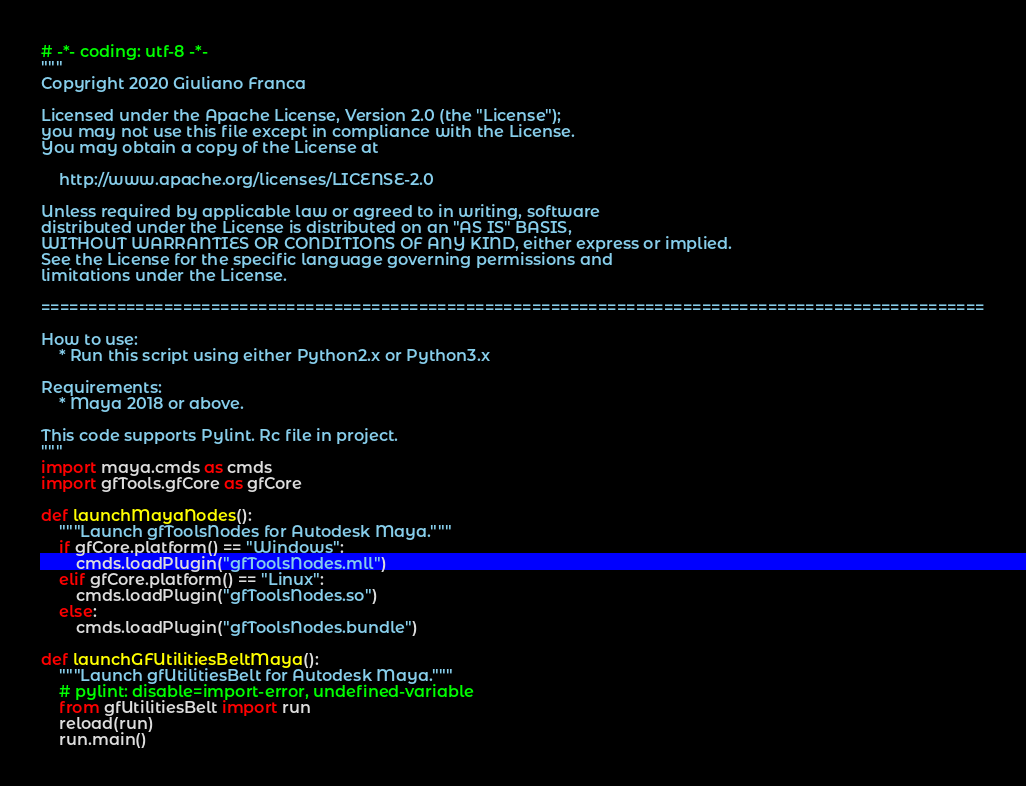Convert code to text. <code><loc_0><loc_0><loc_500><loc_500><_Python_># -*- coding: utf-8 -*-
"""
Copyright 2020 Giuliano Franca

Licensed under the Apache License, Version 2.0 (the "License");
you may not use this file except in compliance with the License.
You may obtain a copy of the License at

    http://www.apache.org/licenses/LICENSE-2.0

Unless required by applicable law or agreed to in writing, software
distributed under the License is distributed on an "AS IS" BASIS,
WITHOUT WARRANTIES OR CONDITIONS OF ANY KIND, either express or implied.
See the License for the specific language governing permissions and
limitations under the License.

====================================================================================================

How to use:
    * Run this script using either Python2.x or Python3.x

Requirements:
    * Maya 2018 or above.

This code supports Pylint. Rc file in project.
"""
import maya.cmds as cmds
import gfTools.gfCore as gfCore

def launchMayaNodes():
    """Launch gfToolsNodes for Autodesk Maya."""
    if gfCore.platform() == "Windows":
        cmds.loadPlugin("gfToolsNodes.mll")
    elif gfCore.platform() == "Linux":
        cmds.loadPlugin("gfToolsNodes.so")
    else:
        cmds.loadPlugin("gfToolsNodes.bundle")

def launchGFUtilitiesBeltMaya():
    """Launch gfUtilitiesBelt for Autodesk Maya."""
    # pylint: disable=import-error, undefined-variable
    from gfUtilitiesBelt import run
    reload(run)
    run.main()
</code> 